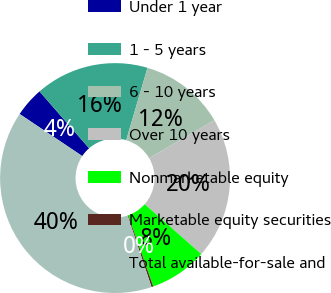Convert chart. <chart><loc_0><loc_0><loc_500><loc_500><pie_chart><fcel>Under 1 year<fcel>1 - 5 years<fcel>6 - 10 years<fcel>Over 10 years<fcel>Nonmarketable equity<fcel>Marketable equity securities<fcel>Total available-for-sale and<nl><fcel>4.18%<fcel>15.97%<fcel>12.04%<fcel>19.9%<fcel>8.11%<fcel>0.25%<fcel>39.55%<nl></chart> 